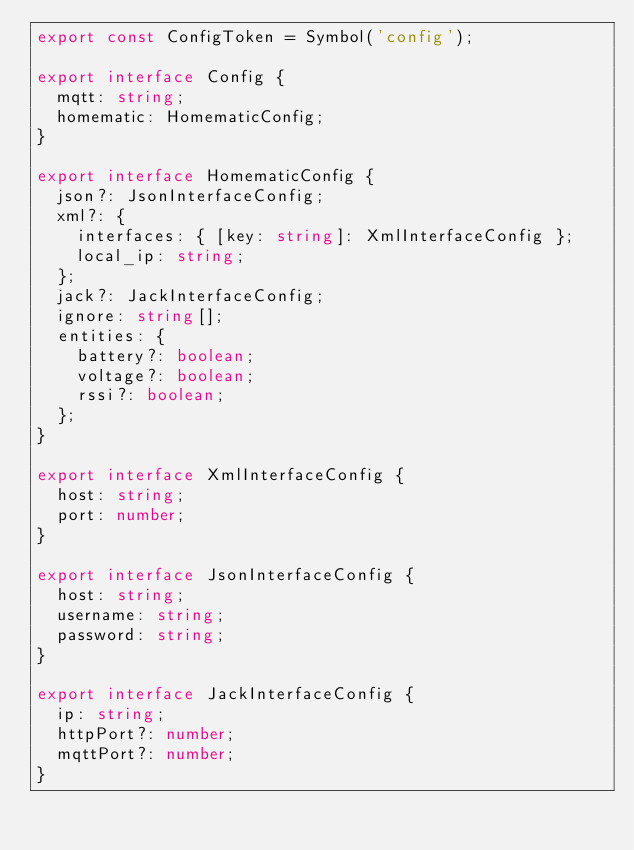Convert code to text. <code><loc_0><loc_0><loc_500><loc_500><_TypeScript_>export const ConfigToken = Symbol('config');

export interface Config {
  mqtt: string;
  homematic: HomematicConfig;
}

export interface HomematicConfig {
  json?: JsonInterfaceConfig;
  xml?: {
    interfaces: { [key: string]: XmlInterfaceConfig };
    local_ip: string;
  };
  jack?: JackInterfaceConfig;
  ignore: string[];
  entities: {
    battery?: boolean;
    voltage?: boolean;
    rssi?: boolean;
  };
}

export interface XmlInterfaceConfig {
  host: string;
  port: number;
}

export interface JsonInterfaceConfig {
  host: string;
  username: string;
  password: string;
}

export interface JackInterfaceConfig {
  ip: string;
  httpPort?: number;
  mqttPort?: number;
}
</code> 